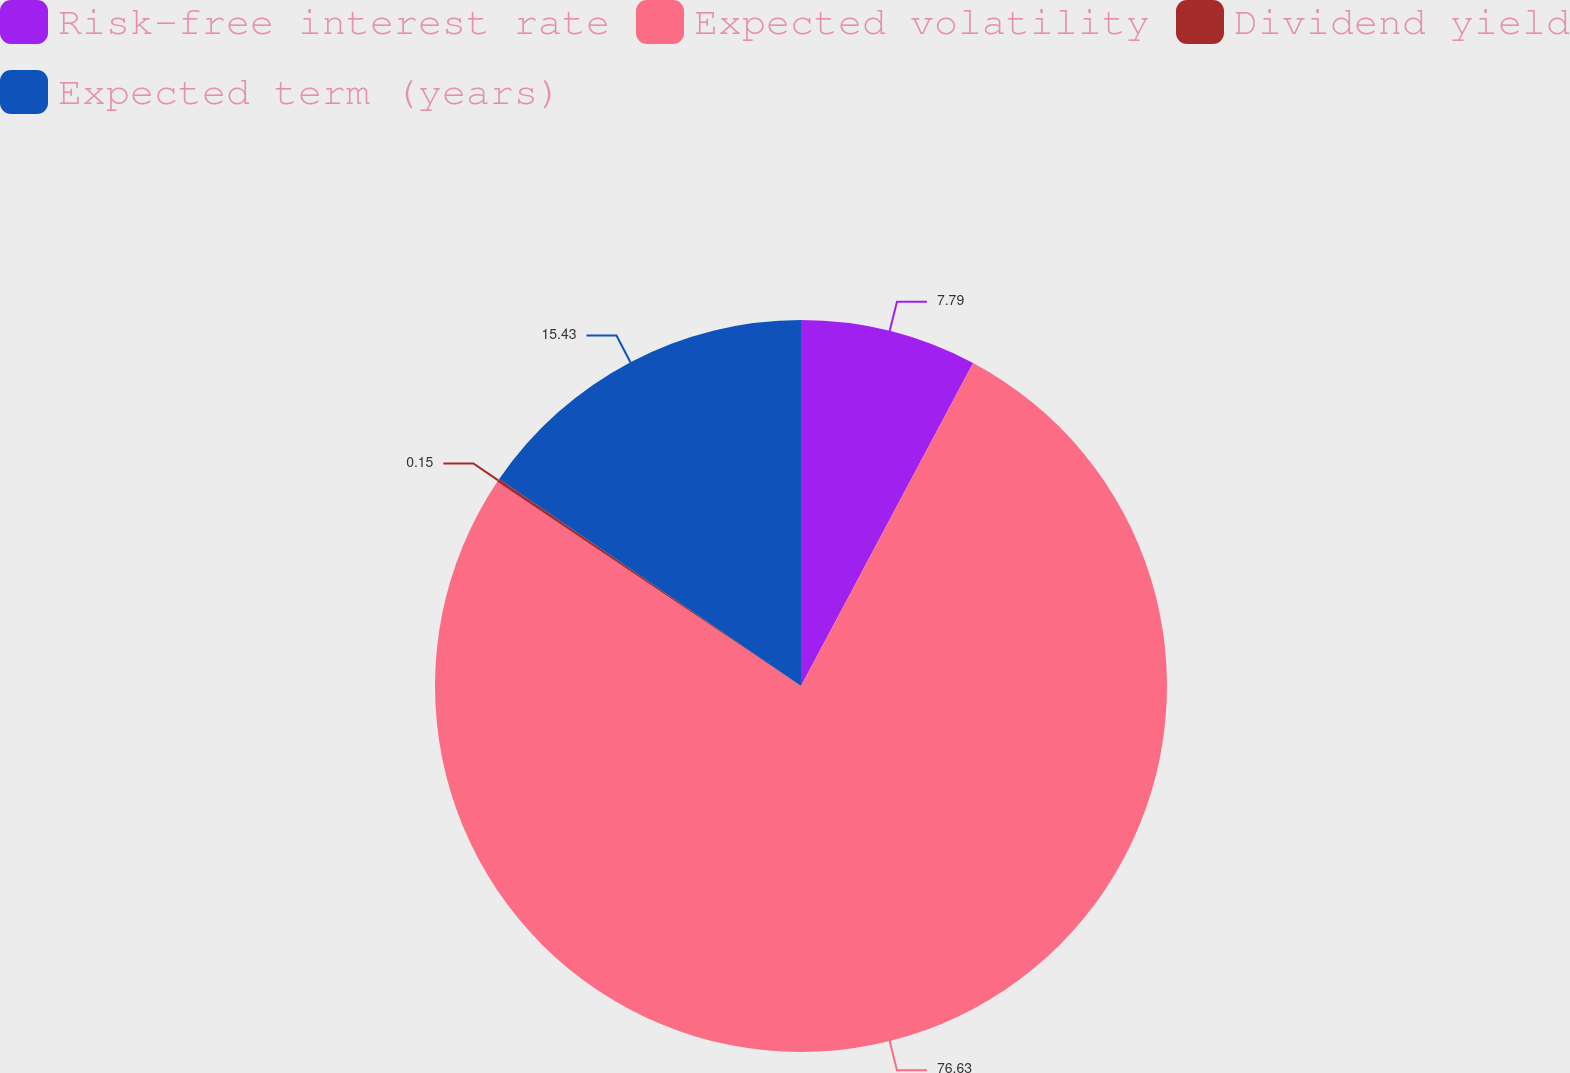Convert chart. <chart><loc_0><loc_0><loc_500><loc_500><pie_chart><fcel>Risk-free interest rate<fcel>Expected volatility<fcel>Dividend yield<fcel>Expected term (years)<nl><fcel>7.79%<fcel>76.63%<fcel>0.15%<fcel>15.43%<nl></chart> 